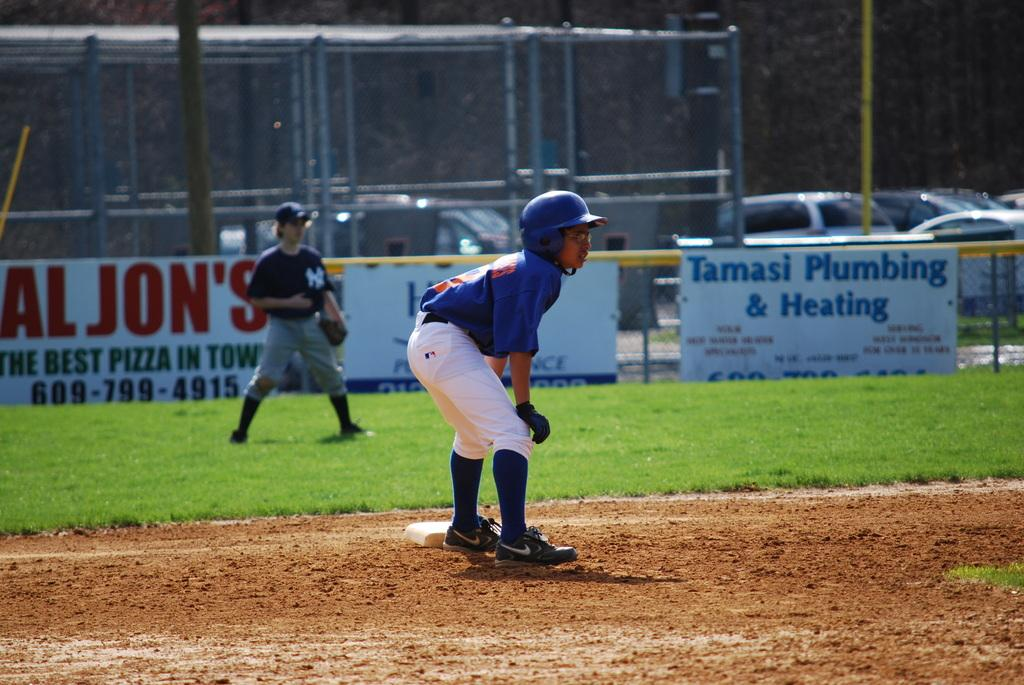<image>
Relay a brief, clear account of the picture shown. a tamasi plumbing and heating sign on the field 